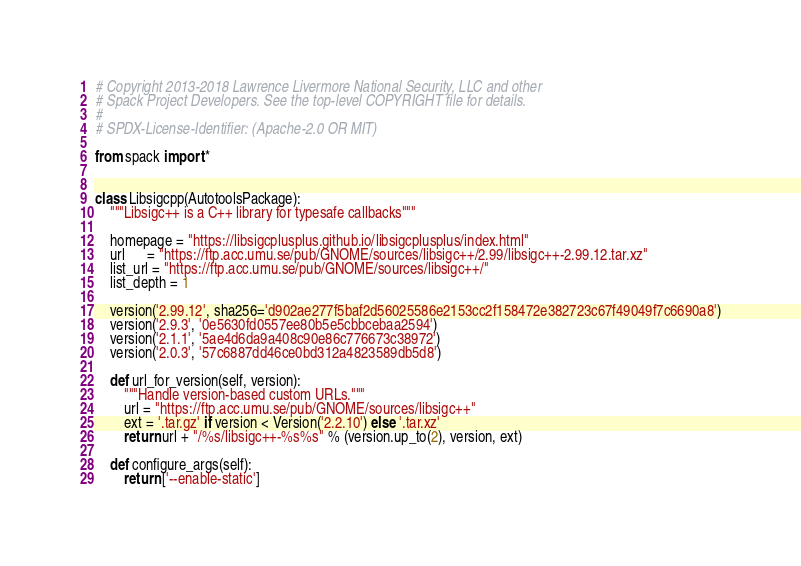Convert code to text. <code><loc_0><loc_0><loc_500><loc_500><_Python_># Copyright 2013-2018 Lawrence Livermore National Security, LLC and other
# Spack Project Developers. See the top-level COPYRIGHT file for details.
#
# SPDX-License-Identifier: (Apache-2.0 OR MIT)

from spack import *


class Libsigcpp(AutotoolsPackage):
    """Libsigc++ is a C++ library for typesafe callbacks"""

    homepage = "https://libsigcplusplus.github.io/libsigcplusplus/index.html"
    url      = "https://ftp.acc.umu.se/pub/GNOME/sources/libsigc++/2.99/libsigc++-2.99.12.tar.xz"
    list_url = "https://ftp.acc.umu.se/pub/GNOME/sources/libsigc++/"
    list_depth = 1

    version('2.99.12', sha256='d902ae277f5baf2d56025586e2153cc2f158472e382723c67f49049f7c6690a8')
    version('2.9.3', '0e5630fd0557ee80b5e5cbbcebaa2594')
    version('2.1.1', '5ae4d6da9a408c90e86c776673c38972')
    version('2.0.3', '57c6887dd46ce0bd312a4823589db5d8')

    def url_for_version(self, version):
        """Handle version-based custom URLs."""
        url = "https://ftp.acc.umu.se/pub/GNOME/sources/libsigc++"
        ext = '.tar.gz' if version < Version('2.2.10') else '.tar.xz'
        return url + "/%s/libsigc++-%s%s" % (version.up_to(2), version, ext)

    def configure_args(self):
        return ['--enable-static']
</code> 